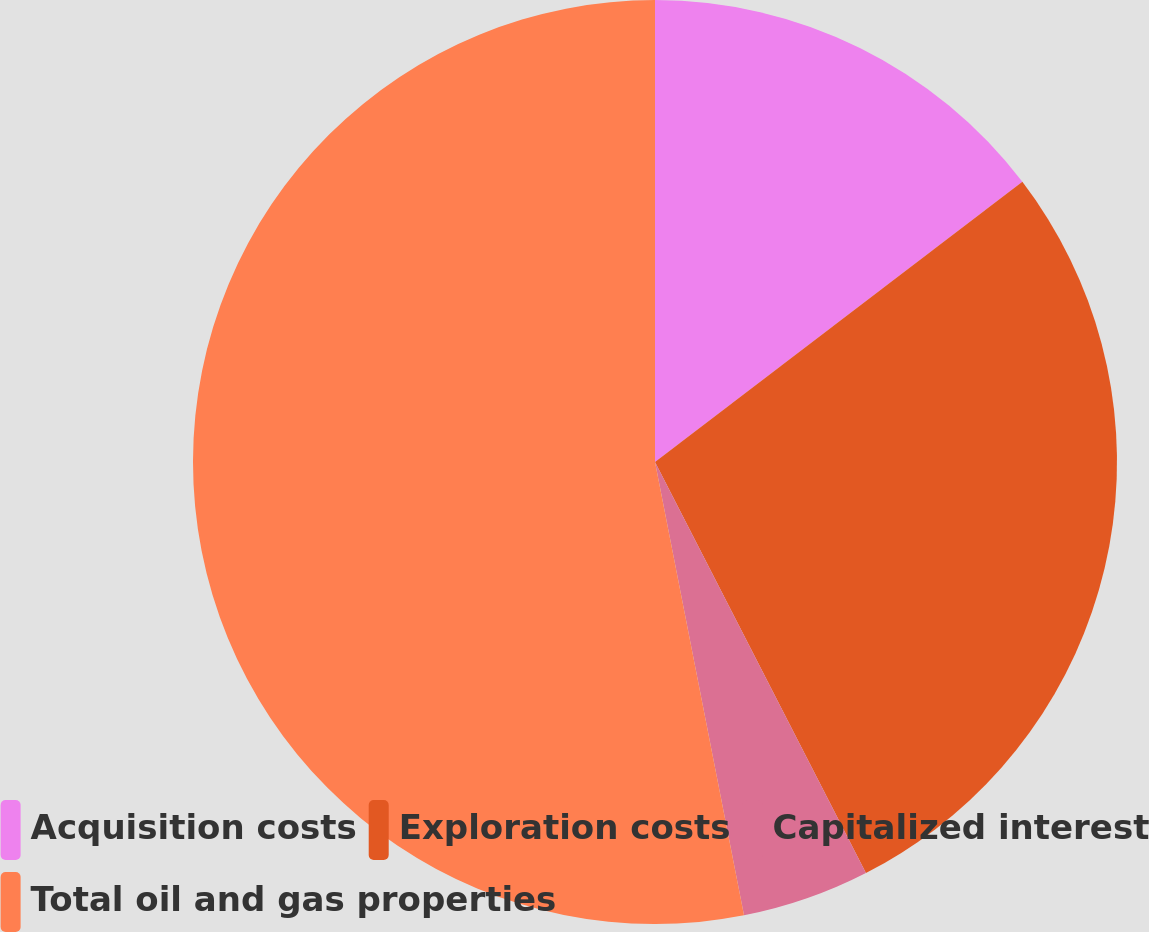Convert chart to OTSL. <chart><loc_0><loc_0><loc_500><loc_500><pie_chart><fcel>Acquisition costs<fcel>Exploration costs<fcel>Capitalized interest<fcel>Total oil and gas properties<nl><fcel>14.63%<fcel>27.82%<fcel>4.46%<fcel>53.08%<nl></chart> 